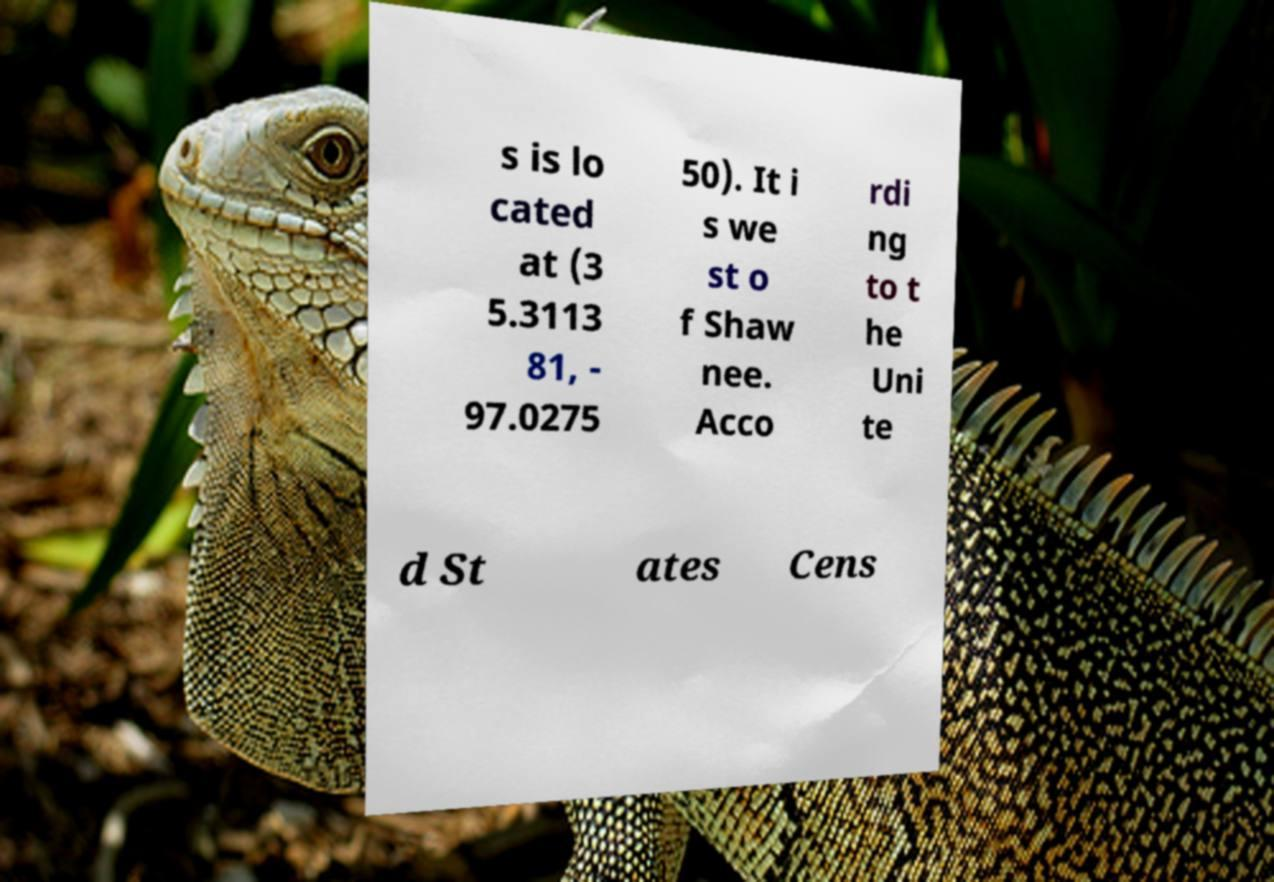There's text embedded in this image that I need extracted. Can you transcribe it verbatim? s is lo cated at (3 5.3113 81, - 97.0275 50). It i s we st o f Shaw nee. Acco rdi ng to t he Uni te d St ates Cens 